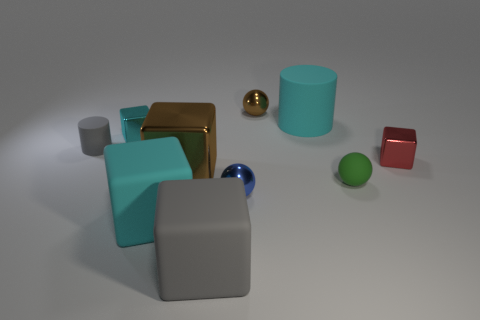Subtract all cyan metal cubes. How many cubes are left? 4 Subtract all red blocks. How many blocks are left? 4 Subtract all blue blocks. Subtract all brown spheres. How many blocks are left? 5 Subtract all cylinders. How many objects are left? 8 Add 8 cylinders. How many cylinders are left? 10 Add 5 small red blocks. How many small red blocks exist? 6 Subtract 1 cyan cylinders. How many objects are left? 9 Subtract all purple blocks. Subtract all big gray cubes. How many objects are left? 9 